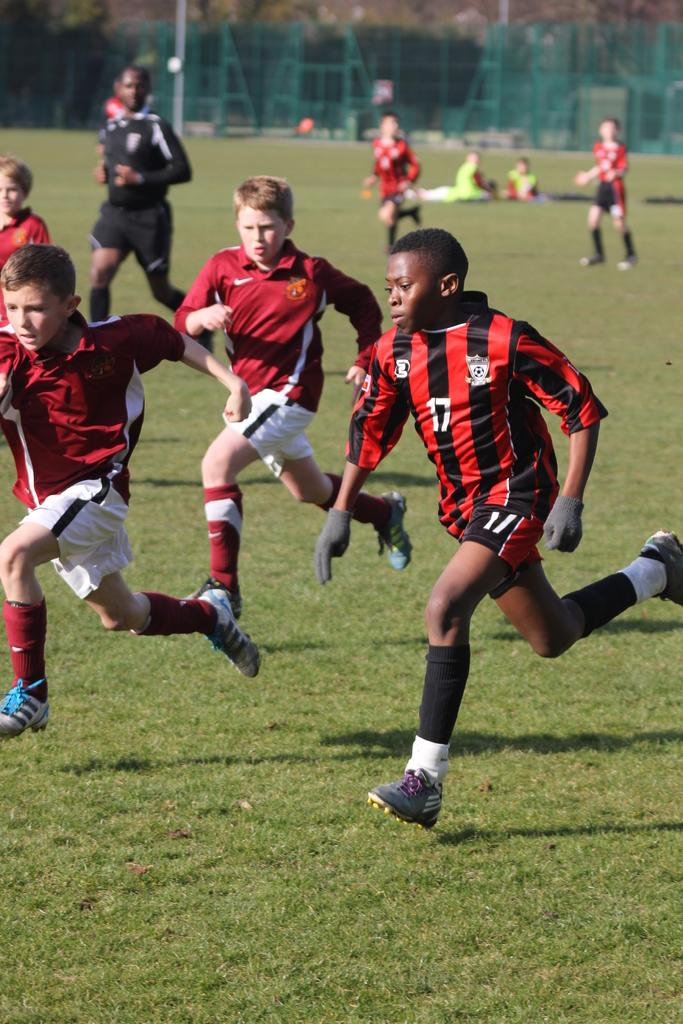<image>
Render a clear and concise summary of the photo. Child soccer players are running down a field and the player number 17 is in the foreground. 